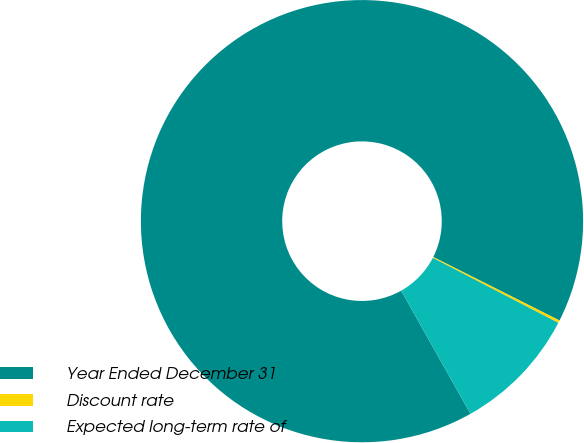Convert chart to OTSL. <chart><loc_0><loc_0><loc_500><loc_500><pie_chart><fcel>Year Ended December 31<fcel>Discount rate<fcel>Expected long-term rate of<nl><fcel>90.58%<fcel>0.19%<fcel>9.23%<nl></chart> 